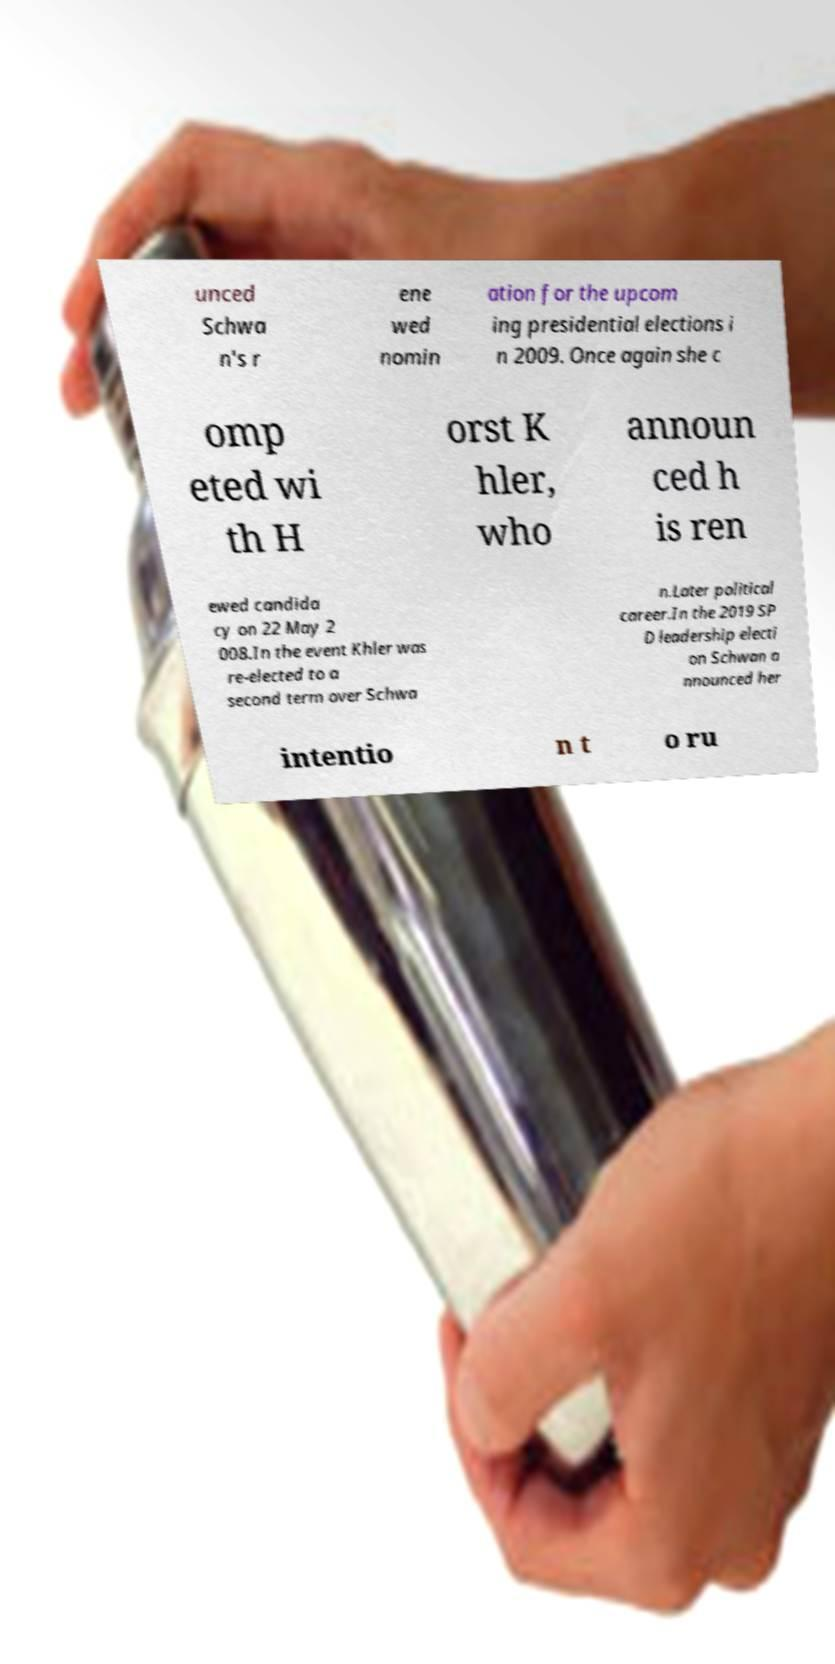Could you extract and type out the text from this image? unced Schwa n's r ene wed nomin ation for the upcom ing presidential elections i n 2009. Once again she c omp eted wi th H orst K hler, who announ ced h is ren ewed candida cy on 22 May 2 008.In the event Khler was re-elected to a second term over Schwa n.Later political career.In the 2019 SP D leadership electi on Schwan a nnounced her intentio n t o ru 